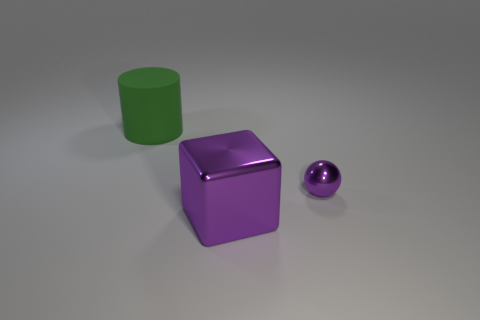Add 1 purple spheres. How many objects exist? 4 Subtract all blocks. How many objects are left? 2 Subtract all green balls. Subtract all big objects. How many objects are left? 1 Add 3 large purple metallic blocks. How many large purple metallic blocks are left? 4 Add 1 small gray rubber balls. How many small gray rubber balls exist? 1 Subtract 0 purple cylinders. How many objects are left? 3 